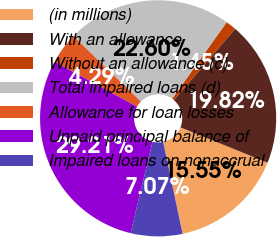<chart> <loc_0><loc_0><loc_500><loc_500><pie_chart><fcel>(in millions)<fcel>With an allowance<fcel>Without an allowance (c)<fcel>Total impaired loans (d)<fcel>Allowance for loan losses<fcel>Unpaid principal balance of<fcel>Impaired loans on nonaccrual<nl><fcel>15.55%<fcel>19.82%<fcel>1.45%<fcel>22.6%<fcel>4.29%<fcel>29.21%<fcel>7.07%<nl></chart> 